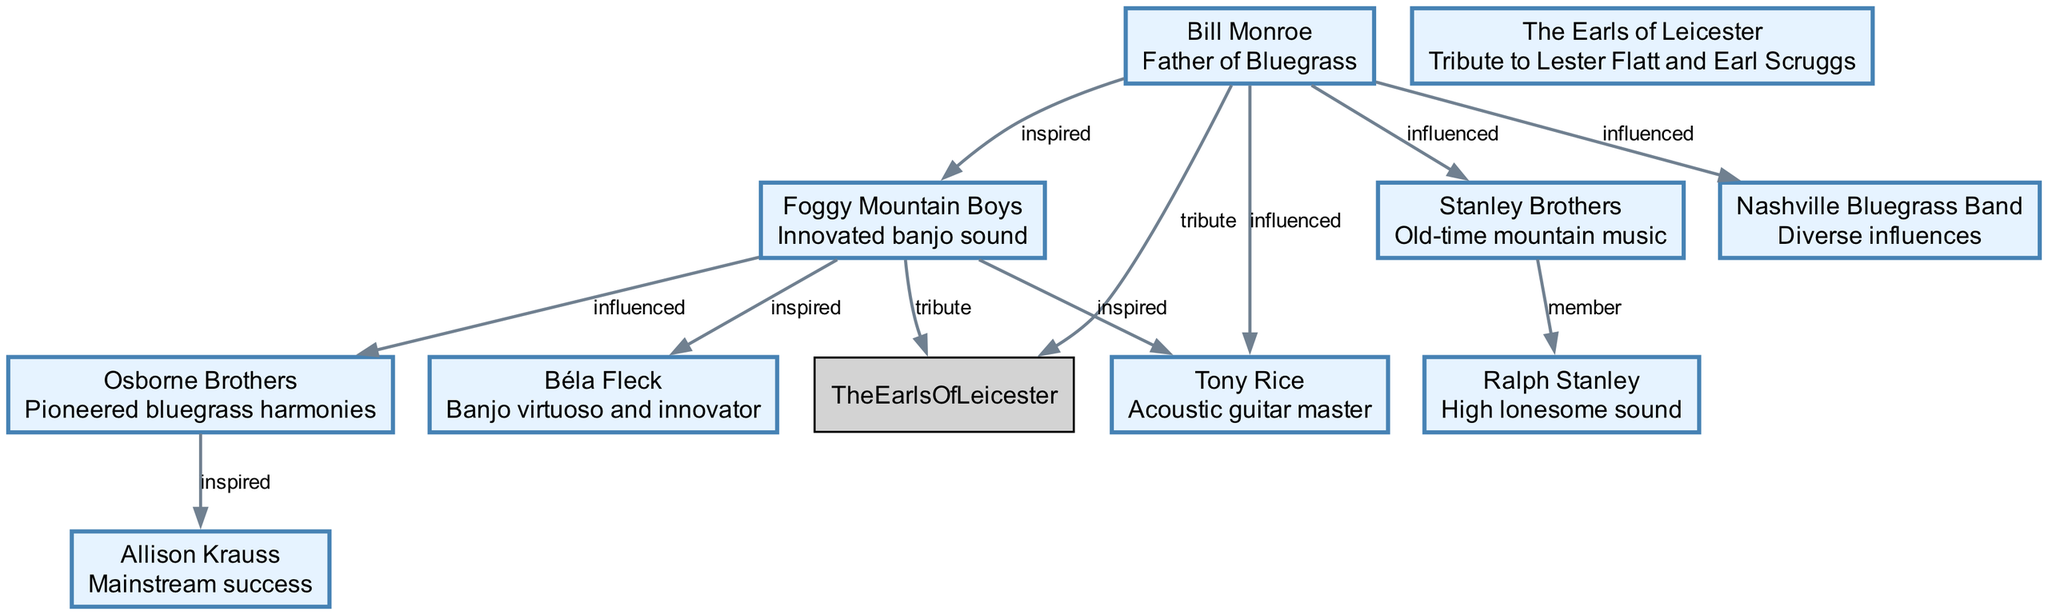What is the central figure in the bluegrass music diagram? The diagram highlights Bill Monroe as the central figure, often referred to as the "Father of Bluegrass" due to his significant contributions to the genre.
Answer: Bill Monroe How many musicians or bands are represented in the diagram? There are a total of ten nodes representing musicians and bands, highlighting their distinct contributions and influences within bluegrass music.
Answer: 10 Which band is recognized for innovating the banjo sound? The Foggy Mountain Boys are noted in the diagram for their innovation in the banjo sound, making a memorable mark in bluegrass history.
Answer: Foggy Mountain Boys Who inspired Allison Krauss in her music career? The Osborne Brothers inspired Allison Krauss, as indicated in the diagram, reflecting the influence of harmonies they pioneered.
Answer: Osborne Brothers What relationship exists between the Stanley Brothers and Ralph Stanley? The diagram shows that Ralph Stanley was a member of the Stanley Brothers, indicating their collaboration and role in bluegrass music together.
Answer: member Which two groups are associated as tributes to Lester Flatt and Earl Scruggs? The Earls of Leicester and the Foggy Mountain Boys are both indicated to be tributes to the influential figures of Lester Flatt and Earl Scruggs, showcasing their homage to these legends.
Answer: The Earls of Leicester and Foggy Mountain Boys Which musician is known as a banjo virtuoso and innovator? Béla Fleck is recognized in the diagram as a banjo virtuoso and innovator, emphasizing his contributions to advancing the instrument in bluegrass.
Answer: Béla Fleck How is Bill Monroe linked to the Nashville Bluegrass Band? The diagram illustrates that Bill Monroe influenced the Nashville Bluegrass Band, indicating his role in shaping various elements of the band’s music.
Answer: influenced What type of sound is Ralph Stanley famously associated with? Ralph Stanley is specifically associated with the "high lonesome sound," a term reflective of his unique vocal style and musical signature in bluegrass.
Answer: high lonesome sound 